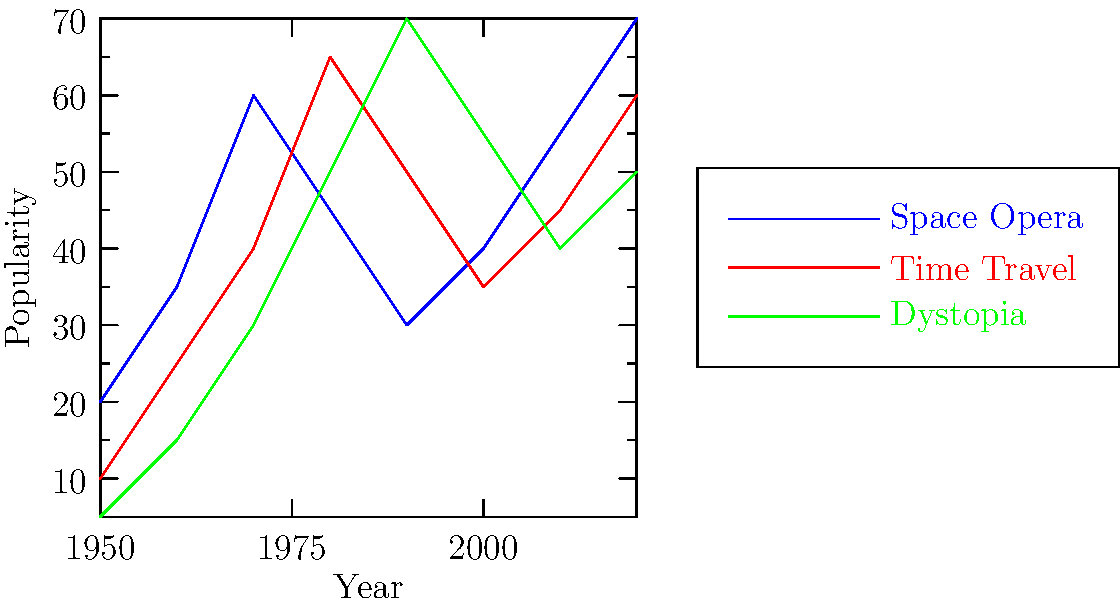Based on the line graph depicting the popularity of science fiction themes over decades, which theme experienced the most significant increase in popularity between 1950 and 1980? To determine which science fiction theme experienced the most significant increase in popularity between 1950 and 1980, we need to compare the change in popularity for each theme:

1. Space Opera (blue line):
   1950: 20
   1980: 45
   Increase: 45 - 20 = 25

2. Time Travel (red line):
   1950: 10
   1980: 65
   Increase: 65 - 10 = 55

3. Dystopia (green line):
   1950: 5
   1980: 50
   Increase: 50 - 5 = 45

Comparing the increases:
Time Travel: 55
Dystopia: 45
Space Opera: 25

The theme with the most significant increase in popularity between 1950 and 1980 is Time Travel, with an increase of 55 points.
Answer: Time Travel 